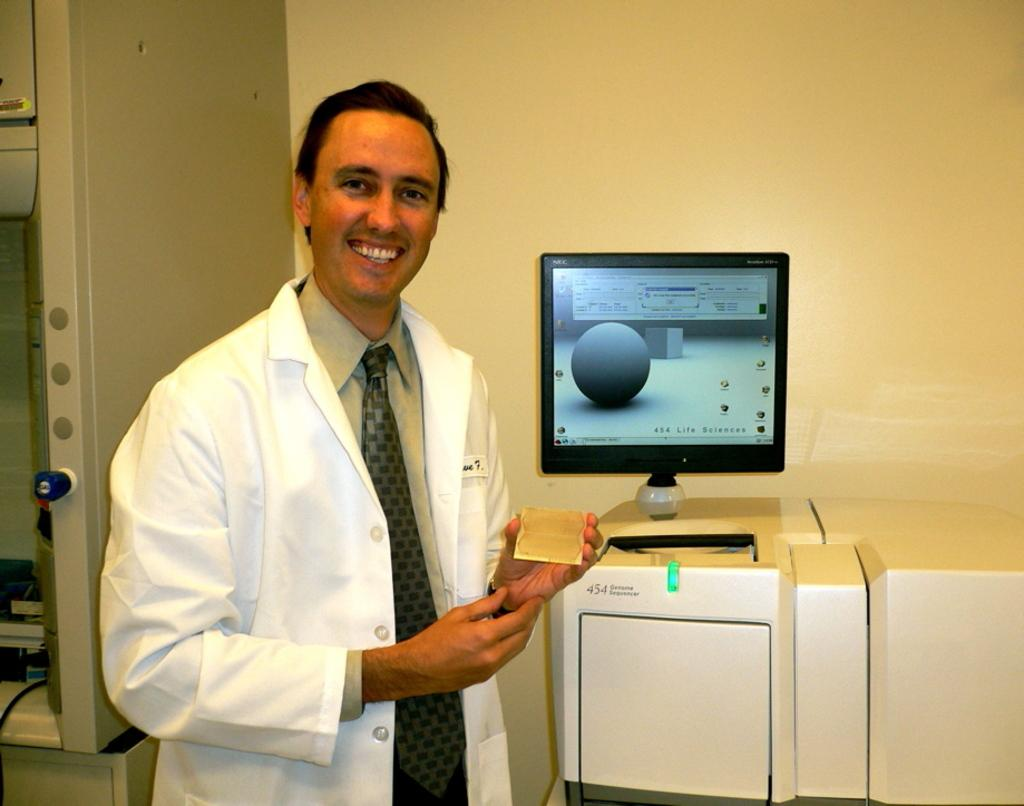What is the main subject of the picture? The main subject of the picture is a man. What is the man doing in the image? The man is standing in the image. What is the man holding in his hand? The man is holding a glass in his hand. What can be seen on the monitor in the image? There is a monitor displaying something in the image. What type of map is the man holding in the image? There is no map present in the image; the man is holding a glass. 